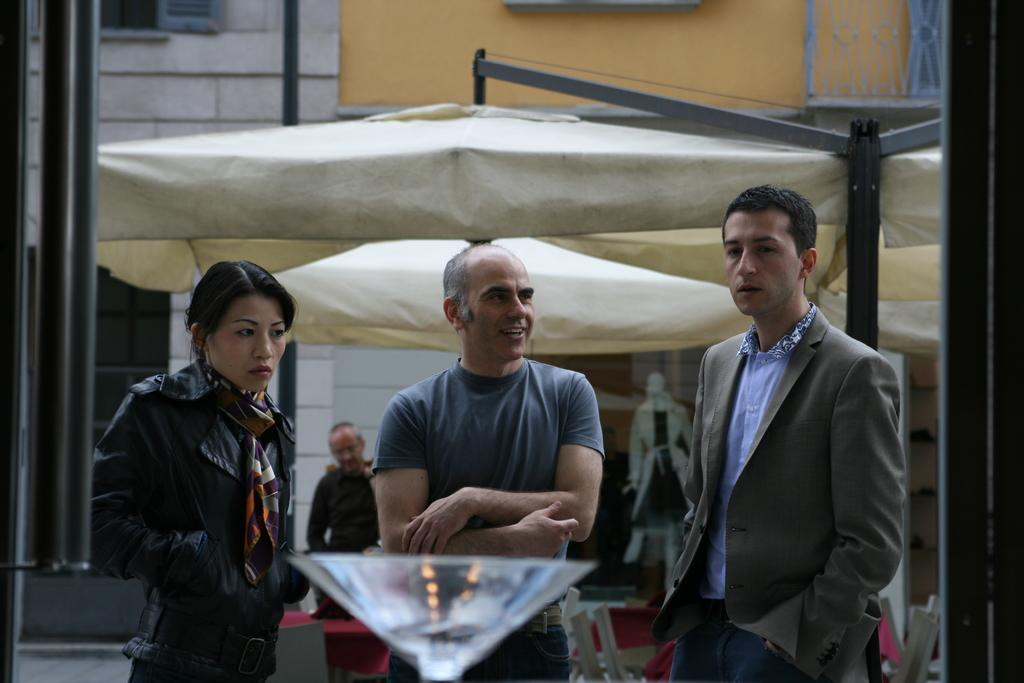What can be seen in the image regarding human presence? There are people standing in the image. Can you identify any specific individuals in the image? Yes, there is a woman in the image. What type of structure is visible in the image? There is a tent and a building in the image. Are there any inanimate objects present in the image? Yes, there is a mannequin and poles in the image. Can you describe the beast grazing near the lake in the image? There is no beast or lake present in the image. 